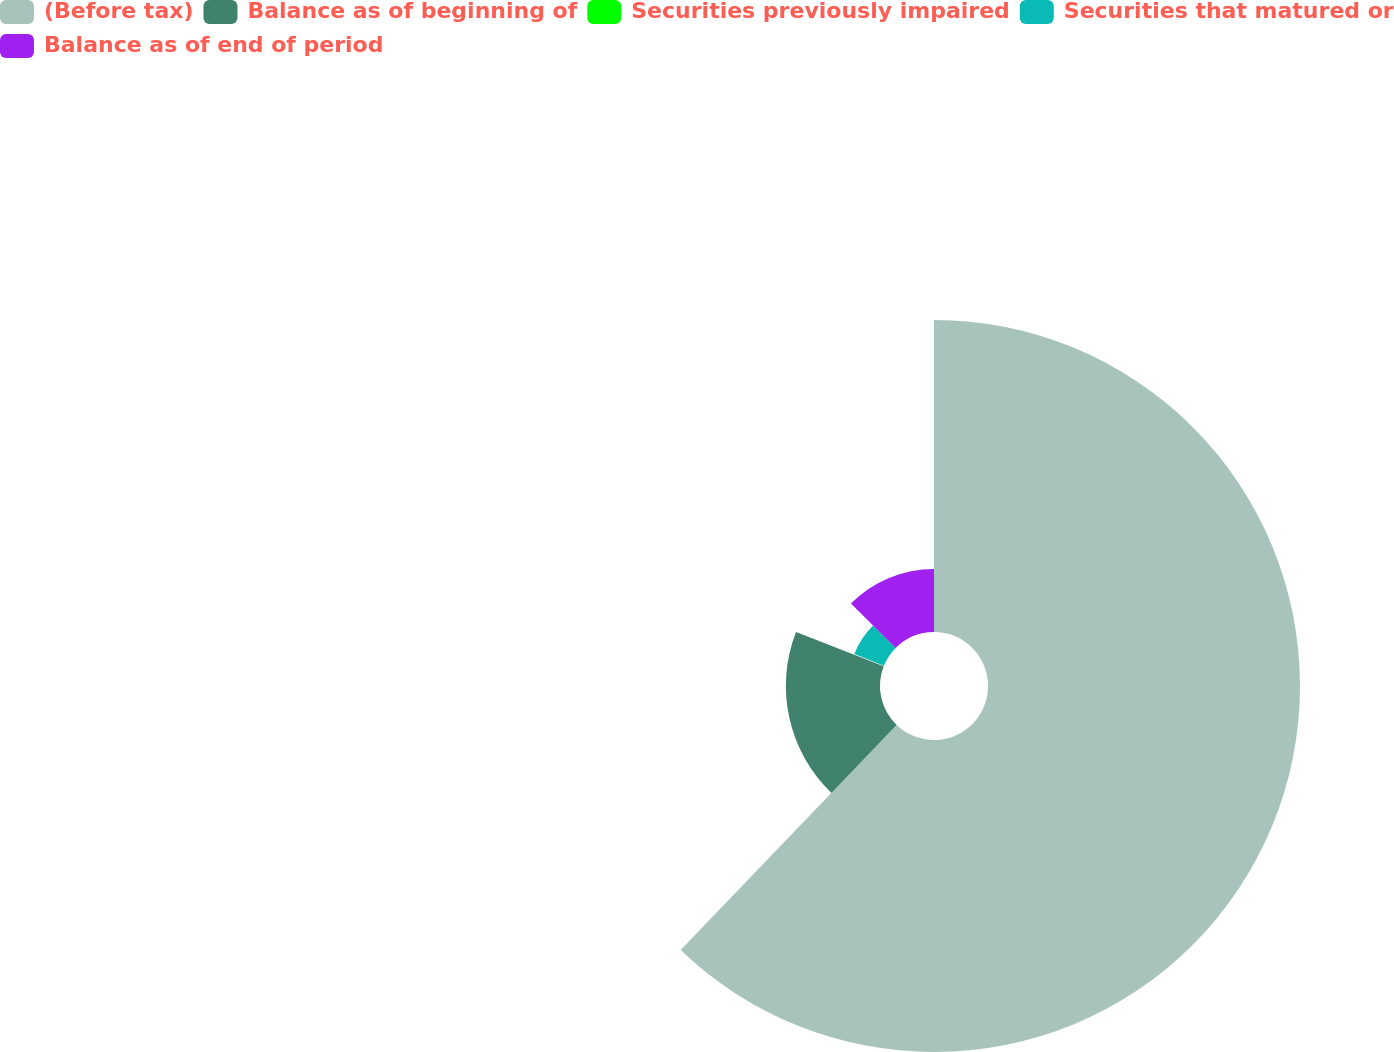Convert chart to OTSL. <chart><loc_0><loc_0><loc_500><loc_500><pie_chart><fcel>(Before tax)<fcel>Balance as of beginning of<fcel>Securities previously impaired<fcel>Securities that matured or<fcel>Balance as of end of period<nl><fcel>62.17%<fcel>18.76%<fcel>0.15%<fcel>6.36%<fcel>12.56%<nl></chart> 